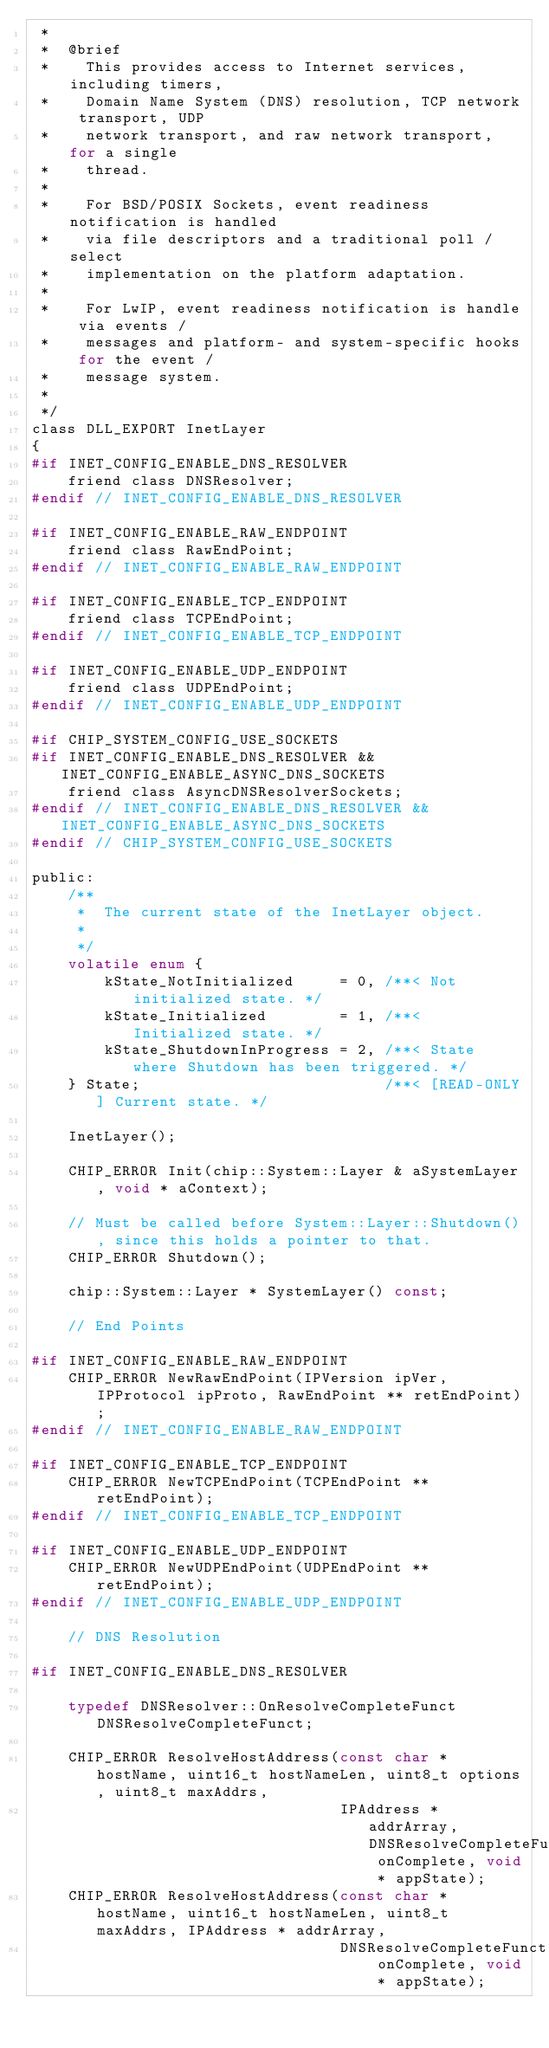Convert code to text. <code><loc_0><loc_0><loc_500><loc_500><_C_> *
 *  @brief
 *    This provides access to Internet services, including timers,
 *    Domain Name System (DNS) resolution, TCP network transport, UDP
 *    network transport, and raw network transport, for a single
 *    thread.
 *
 *    For BSD/POSIX Sockets, event readiness notification is handled
 *    via file descriptors and a traditional poll / select
 *    implementation on the platform adaptation.
 *
 *    For LwIP, event readiness notification is handle via events /
 *    messages and platform- and system-specific hooks for the event /
 *    message system.
 *
 */
class DLL_EXPORT InetLayer
{
#if INET_CONFIG_ENABLE_DNS_RESOLVER
    friend class DNSResolver;
#endif // INET_CONFIG_ENABLE_DNS_RESOLVER

#if INET_CONFIG_ENABLE_RAW_ENDPOINT
    friend class RawEndPoint;
#endif // INET_CONFIG_ENABLE_RAW_ENDPOINT

#if INET_CONFIG_ENABLE_TCP_ENDPOINT
    friend class TCPEndPoint;
#endif // INET_CONFIG_ENABLE_TCP_ENDPOINT

#if INET_CONFIG_ENABLE_UDP_ENDPOINT
    friend class UDPEndPoint;
#endif // INET_CONFIG_ENABLE_UDP_ENDPOINT

#if CHIP_SYSTEM_CONFIG_USE_SOCKETS
#if INET_CONFIG_ENABLE_DNS_RESOLVER && INET_CONFIG_ENABLE_ASYNC_DNS_SOCKETS
    friend class AsyncDNSResolverSockets;
#endif // INET_CONFIG_ENABLE_DNS_RESOLVER && INET_CONFIG_ENABLE_ASYNC_DNS_SOCKETS
#endif // CHIP_SYSTEM_CONFIG_USE_SOCKETS

public:
    /**
     *  The current state of the InetLayer object.
     *
     */
    volatile enum {
        kState_NotInitialized     = 0, /**< Not initialized state. */
        kState_Initialized        = 1, /**< Initialized state. */
        kState_ShutdownInProgress = 2, /**< State where Shutdown has been triggered. */
    } State;                           /**< [READ-ONLY] Current state. */

    InetLayer();

    CHIP_ERROR Init(chip::System::Layer & aSystemLayer, void * aContext);

    // Must be called before System::Layer::Shutdown(), since this holds a pointer to that.
    CHIP_ERROR Shutdown();

    chip::System::Layer * SystemLayer() const;

    // End Points

#if INET_CONFIG_ENABLE_RAW_ENDPOINT
    CHIP_ERROR NewRawEndPoint(IPVersion ipVer, IPProtocol ipProto, RawEndPoint ** retEndPoint);
#endif // INET_CONFIG_ENABLE_RAW_ENDPOINT

#if INET_CONFIG_ENABLE_TCP_ENDPOINT
    CHIP_ERROR NewTCPEndPoint(TCPEndPoint ** retEndPoint);
#endif // INET_CONFIG_ENABLE_TCP_ENDPOINT

#if INET_CONFIG_ENABLE_UDP_ENDPOINT
    CHIP_ERROR NewUDPEndPoint(UDPEndPoint ** retEndPoint);
#endif // INET_CONFIG_ENABLE_UDP_ENDPOINT

    // DNS Resolution

#if INET_CONFIG_ENABLE_DNS_RESOLVER

    typedef DNSResolver::OnResolveCompleteFunct DNSResolveCompleteFunct;

    CHIP_ERROR ResolveHostAddress(const char * hostName, uint16_t hostNameLen, uint8_t options, uint8_t maxAddrs,
                                  IPAddress * addrArray, DNSResolveCompleteFunct onComplete, void * appState);
    CHIP_ERROR ResolveHostAddress(const char * hostName, uint16_t hostNameLen, uint8_t maxAddrs, IPAddress * addrArray,
                                  DNSResolveCompleteFunct onComplete, void * appState);</code> 